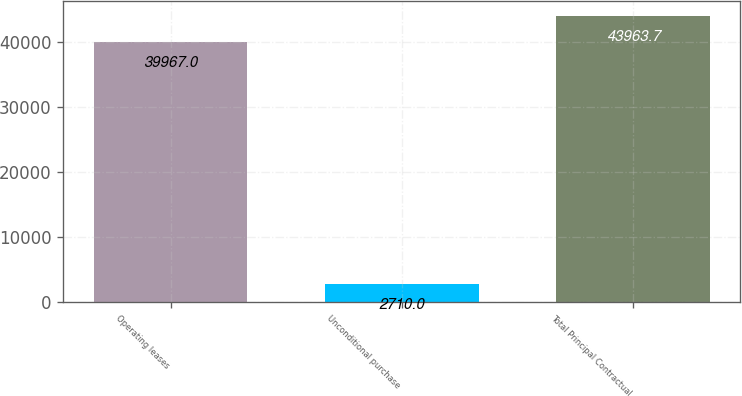Convert chart to OTSL. <chart><loc_0><loc_0><loc_500><loc_500><bar_chart><fcel>Operating leases<fcel>Unconditional purchase<fcel>Total Principal Contractual<nl><fcel>39967<fcel>2710<fcel>43963.7<nl></chart> 